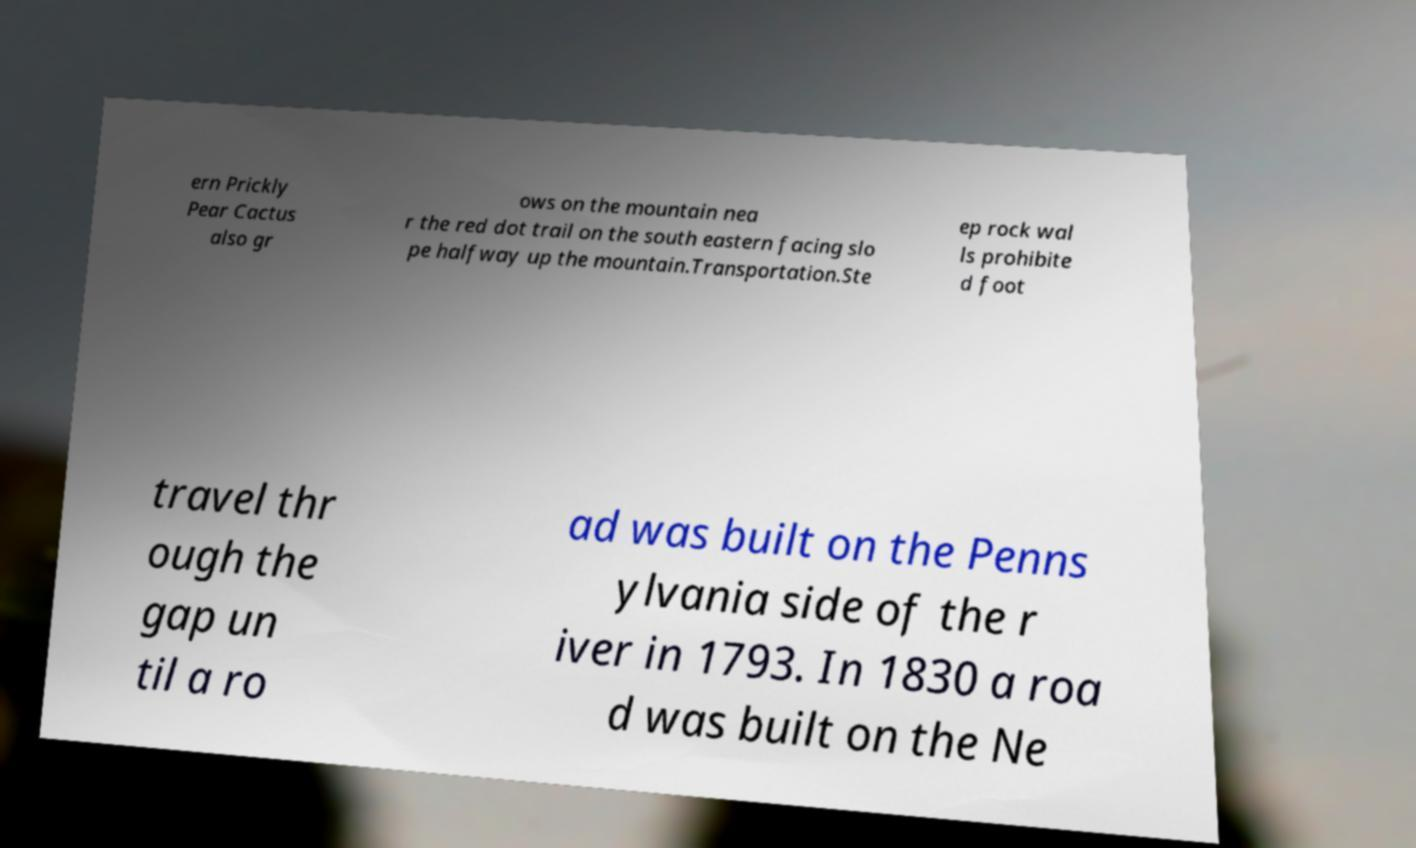Can you accurately transcribe the text from the provided image for me? ern Prickly Pear Cactus also gr ows on the mountain nea r the red dot trail on the south eastern facing slo pe halfway up the mountain.Transportation.Ste ep rock wal ls prohibite d foot travel thr ough the gap un til a ro ad was built on the Penns ylvania side of the r iver in 1793. In 1830 a roa d was built on the Ne 